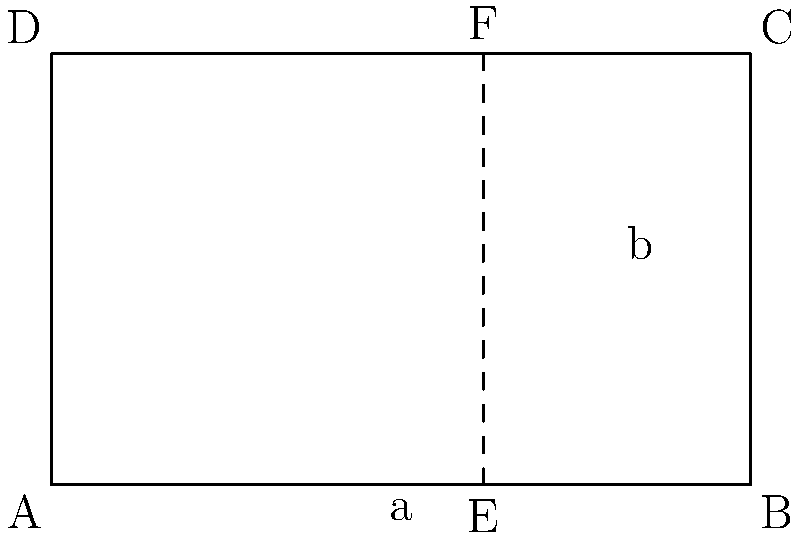As a digital illustrator, you're designing a rectangle for optimal composition using the golden ratio. In the diagram, rectangle ABCD is divided into a square and a smaller rectangle. If the width of the entire rectangle is 100 units, calculate the height of the rectangle to the nearest tenth of a unit, ensuring it follows the golden ratio principle. To solve this problem, we'll use the golden ratio principle and the given information:

1) The golden ratio is approximately 1.618034, often denoted by φ (phi).

2) In a golden rectangle, the ratio of the longer side to the shorter side is equal to φ.

3) We're given that the width of the rectangle is 100 units.

4) Let's call the height of the rectangle h.

5) According to the golden ratio principle:
   $$ \frac{100}{h} = \frac{h}{100-h} = φ $$

6) We can set up the equation:
   $$ \frac{100}{h} = 1.618034 $$

7) Cross-multiply:
   $$ 100 = 1.618034h $$

8) Solve for h:
   $$ h = \frac{100}{1.618034} ≈ 61.8034 $$

9) Rounding to the nearest tenth:
   $$ h ≈ 61.8 \text{ units} $$

Therefore, the height of the golden rectangle should be approximately 61.8 units.
Answer: 61.8 units 